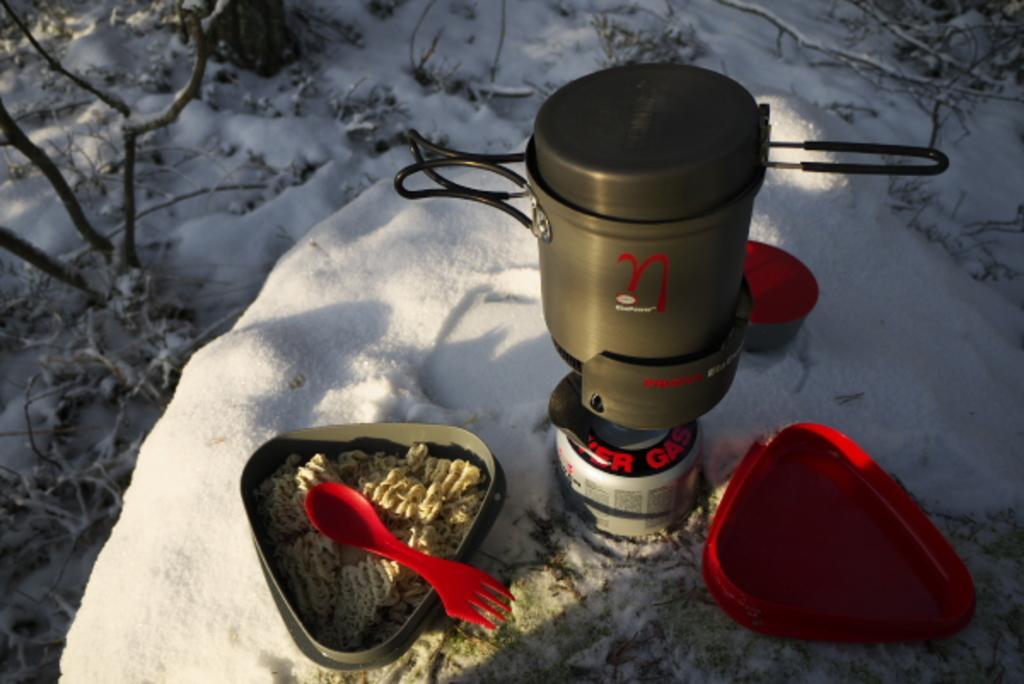Describe this image in one or two sentences. In this image there is a gas stove in the middle. Beside the gas stove there are two boxes. On the left side there is a box which contains noodles in it. At the bottom there is snow. On the right side there is an empty red colour box. 